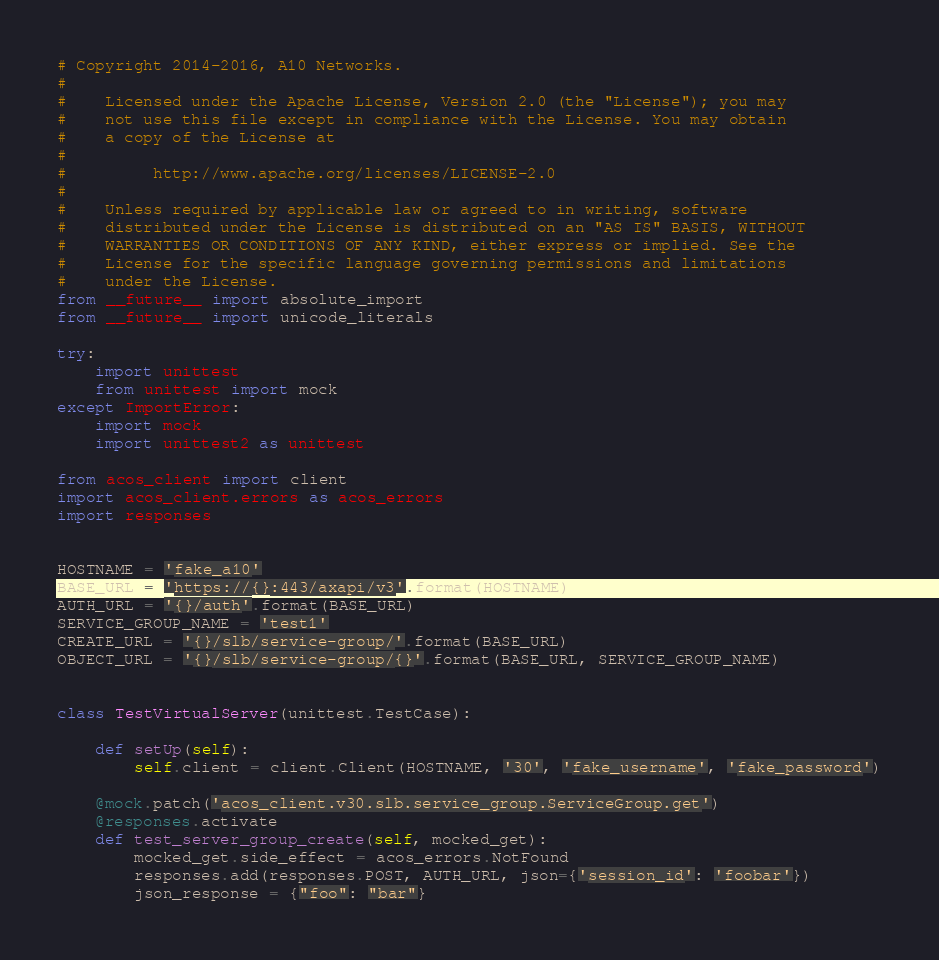Convert code to text. <code><loc_0><loc_0><loc_500><loc_500><_Python_># Copyright 2014-2016, A10 Networks.
#
#    Licensed under the Apache License, Version 2.0 (the "License"); you may
#    not use this file except in compliance with the License. You may obtain
#    a copy of the License at
#
#         http://www.apache.org/licenses/LICENSE-2.0
#
#    Unless required by applicable law or agreed to in writing, software
#    distributed under the License is distributed on an "AS IS" BASIS, WITHOUT
#    WARRANTIES OR CONDITIONS OF ANY KIND, either express or implied. See the
#    License for the specific language governing permissions and limitations
#    under the License.
from __future__ import absolute_import
from __future__ import unicode_literals

try:
    import unittest
    from unittest import mock
except ImportError:
    import mock
    import unittest2 as unittest

from acos_client import client
import acos_client.errors as acos_errors
import responses


HOSTNAME = 'fake_a10'
BASE_URL = 'https://{}:443/axapi/v3'.format(HOSTNAME)
AUTH_URL = '{}/auth'.format(BASE_URL)
SERVICE_GROUP_NAME = 'test1'
CREATE_URL = '{}/slb/service-group/'.format(BASE_URL)
OBJECT_URL = '{}/slb/service-group/{}'.format(BASE_URL, SERVICE_GROUP_NAME)


class TestVirtualServer(unittest.TestCase):

    def setUp(self):
        self.client = client.Client(HOSTNAME, '30', 'fake_username', 'fake_password')

    @mock.patch('acos_client.v30.slb.service_group.ServiceGroup.get')
    @responses.activate
    def test_server_group_create(self, mocked_get):
        mocked_get.side_effect = acos_errors.NotFound
        responses.add(responses.POST, AUTH_URL, json={'session_id': 'foobar'})
        json_response = {"foo": "bar"}</code> 